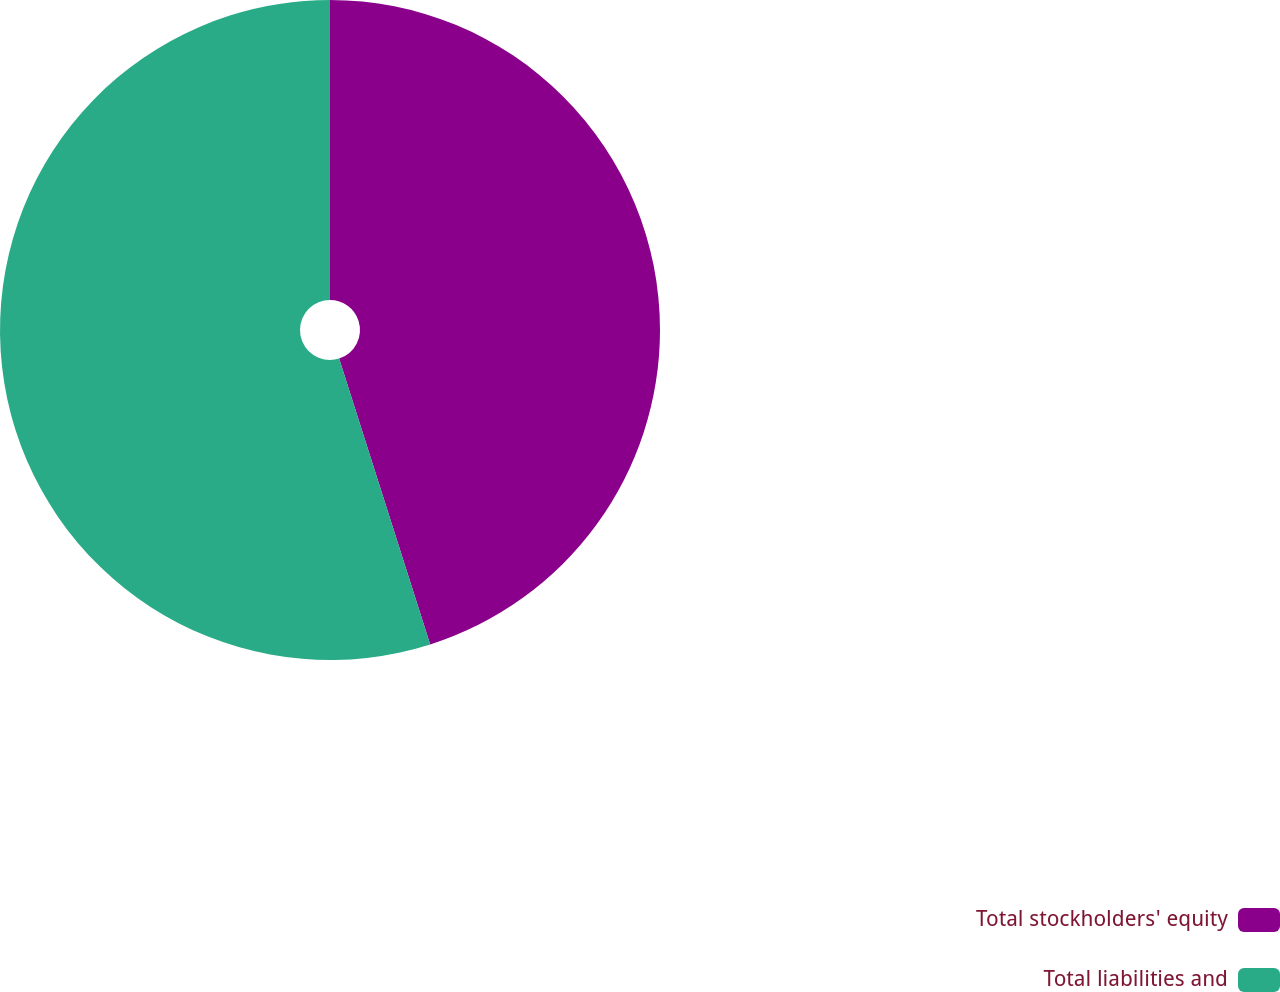Convert chart. <chart><loc_0><loc_0><loc_500><loc_500><pie_chart><fcel>Total stockholders' equity<fcel>Total liabilities and<nl><fcel>45.09%<fcel>54.91%<nl></chart> 